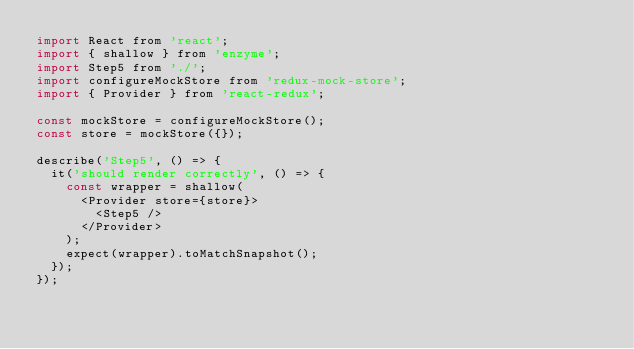<code> <loc_0><loc_0><loc_500><loc_500><_JavaScript_>import React from 'react';
import { shallow } from 'enzyme';
import Step5 from './';
import configureMockStore from 'redux-mock-store';
import { Provider } from 'react-redux';

const mockStore = configureMockStore();
const store = mockStore({});

describe('Step5', () => {
	it('should render correctly', () => {
		const wrapper = shallow(
			<Provider store={store}>
				<Step5 />
			</Provider>
		);
		expect(wrapper).toMatchSnapshot();
	});
});
</code> 